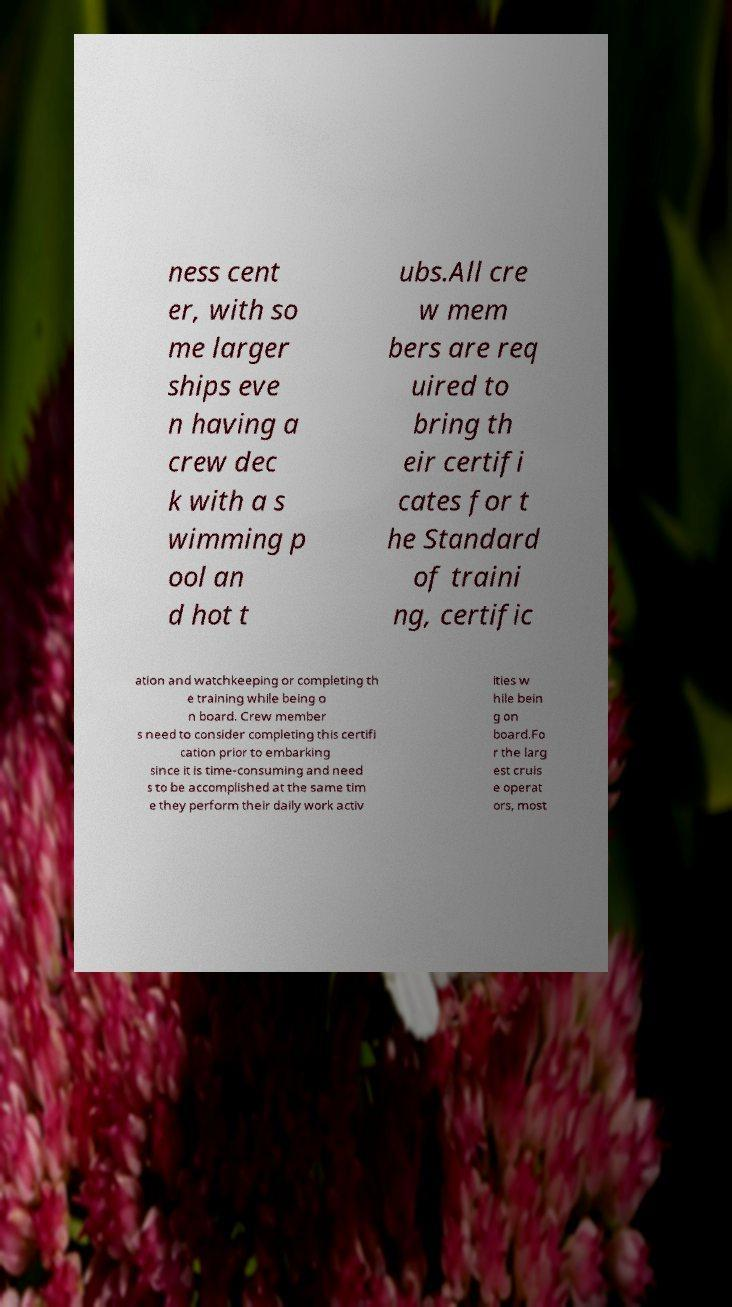For documentation purposes, I need the text within this image transcribed. Could you provide that? ness cent er, with so me larger ships eve n having a crew dec k with a s wimming p ool an d hot t ubs.All cre w mem bers are req uired to bring th eir certifi cates for t he Standard of traini ng, certific ation and watchkeeping or completing th e training while being o n board. Crew member s need to consider completing this certifi cation prior to embarking since it is time-consuming and need s to be accomplished at the same tim e they perform their daily work activ ities w hile bein g on board.Fo r the larg est cruis e operat ors, most 